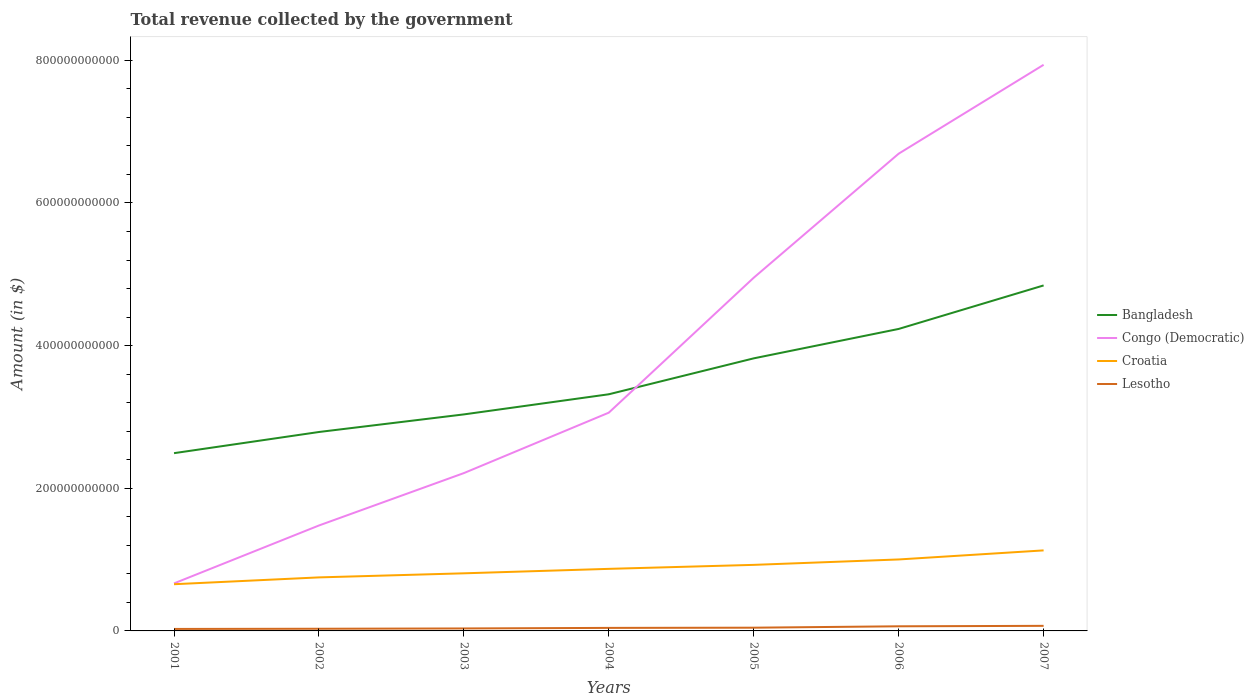How many different coloured lines are there?
Provide a short and direct response. 4. Does the line corresponding to Lesotho intersect with the line corresponding to Bangladesh?
Your answer should be compact. No. Across all years, what is the maximum total revenue collected by the government in Croatia?
Keep it short and to the point. 6.55e+1. In which year was the total revenue collected by the government in Croatia maximum?
Provide a short and direct response. 2001. What is the total total revenue collected by the government in Croatia in the graph?
Your response must be concise. -1.94e+1. What is the difference between the highest and the second highest total revenue collected by the government in Croatia?
Offer a terse response. 4.74e+1. How many lines are there?
Keep it short and to the point. 4. How many years are there in the graph?
Keep it short and to the point. 7. What is the difference between two consecutive major ticks on the Y-axis?
Provide a succinct answer. 2.00e+11. Are the values on the major ticks of Y-axis written in scientific E-notation?
Your answer should be very brief. No. Does the graph contain grids?
Provide a succinct answer. No. How many legend labels are there?
Offer a very short reply. 4. What is the title of the graph?
Your answer should be compact. Total revenue collected by the government. Does "Korea (Republic)" appear as one of the legend labels in the graph?
Offer a very short reply. No. What is the label or title of the Y-axis?
Your answer should be compact. Amount (in $). What is the Amount (in $) of Bangladesh in 2001?
Give a very brief answer. 2.49e+11. What is the Amount (in $) in Congo (Democratic) in 2001?
Provide a short and direct response. 6.66e+1. What is the Amount (in $) in Croatia in 2001?
Make the answer very short. 6.55e+1. What is the Amount (in $) in Lesotho in 2001?
Your answer should be very brief. 2.79e+09. What is the Amount (in $) of Bangladesh in 2002?
Give a very brief answer. 2.79e+11. What is the Amount (in $) in Congo (Democratic) in 2002?
Offer a very short reply. 1.48e+11. What is the Amount (in $) of Croatia in 2002?
Your answer should be compact. 7.51e+1. What is the Amount (in $) in Lesotho in 2002?
Your answer should be very brief. 3.03e+09. What is the Amount (in $) of Bangladesh in 2003?
Provide a succinct answer. 3.04e+11. What is the Amount (in $) of Congo (Democratic) in 2003?
Your answer should be compact. 2.21e+11. What is the Amount (in $) in Croatia in 2003?
Provide a succinct answer. 8.08e+1. What is the Amount (in $) of Lesotho in 2003?
Your answer should be very brief. 3.47e+09. What is the Amount (in $) in Bangladesh in 2004?
Your answer should be compact. 3.32e+11. What is the Amount (in $) of Congo (Democratic) in 2004?
Your response must be concise. 3.06e+11. What is the Amount (in $) of Croatia in 2004?
Give a very brief answer. 8.70e+1. What is the Amount (in $) of Lesotho in 2004?
Offer a very short reply. 4.25e+09. What is the Amount (in $) of Bangladesh in 2005?
Your answer should be compact. 3.82e+11. What is the Amount (in $) in Congo (Democratic) in 2005?
Your response must be concise. 4.95e+11. What is the Amount (in $) in Croatia in 2005?
Provide a succinct answer. 9.26e+1. What is the Amount (in $) of Lesotho in 2005?
Your answer should be compact. 4.53e+09. What is the Amount (in $) of Bangladesh in 2006?
Provide a succinct answer. 4.23e+11. What is the Amount (in $) in Congo (Democratic) in 2006?
Your answer should be compact. 6.69e+11. What is the Amount (in $) in Croatia in 2006?
Ensure brevity in your answer.  1.00e+11. What is the Amount (in $) of Lesotho in 2006?
Your answer should be compact. 6.49e+09. What is the Amount (in $) in Bangladesh in 2007?
Make the answer very short. 4.84e+11. What is the Amount (in $) of Congo (Democratic) in 2007?
Provide a succinct answer. 7.94e+11. What is the Amount (in $) in Croatia in 2007?
Your response must be concise. 1.13e+11. What is the Amount (in $) in Lesotho in 2007?
Give a very brief answer. 7.13e+09. Across all years, what is the maximum Amount (in $) in Bangladesh?
Ensure brevity in your answer.  4.84e+11. Across all years, what is the maximum Amount (in $) in Congo (Democratic)?
Give a very brief answer. 7.94e+11. Across all years, what is the maximum Amount (in $) of Croatia?
Your response must be concise. 1.13e+11. Across all years, what is the maximum Amount (in $) in Lesotho?
Your answer should be compact. 7.13e+09. Across all years, what is the minimum Amount (in $) in Bangladesh?
Your answer should be compact. 2.49e+11. Across all years, what is the minimum Amount (in $) in Congo (Democratic)?
Offer a very short reply. 6.66e+1. Across all years, what is the minimum Amount (in $) in Croatia?
Offer a very short reply. 6.55e+1. Across all years, what is the minimum Amount (in $) of Lesotho?
Offer a terse response. 2.79e+09. What is the total Amount (in $) in Bangladesh in the graph?
Ensure brevity in your answer.  2.45e+12. What is the total Amount (in $) of Congo (Democratic) in the graph?
Make the answer very short. 2.70e+12. What is the total Amount (in $) of Croatia in the graph?
Offer a terse response. 6.14e+11. What is the total Amount (in $) of Lesotho in the graph?
Your answer should be very brief. 3.17e+1. What is the difference between the Amount (in $) in Bangladesh in 2001 and that in 2002?
Keep it short and to the point. -2.97e+1. What is the difference between the Amount (in $) of Congo (Democratic) in 2001 and that in 2002?
Your answer should be compact. -8.12e+1. What is the difference between the Amount (in $) in Croatia in 2001 and that in 2002?
Keep it short and to the point. -9.58e+09. What is the difference between the Amount (in $) of Lesotho in 2001 and that in 2002?
Offer a terse response. -2.46e+08. What is the difference between the Amount (in $) in Bangladesh in 2001 and that in 2003?
Make the answer very short. -5.43e+1. What is the difference between the Amount (in $) of Congo (Democratic) in 2001 and that in 2003?
Your answer should be very brief. -1.55e+11. What is the difference between the Amount (in $) of Croatia in 2001 and that in 2003?
Keep it short and to the point. -1.53e+1. What is the difference between the Amount (in $) in Lesotho in 2001 and that in 2003?
Make the answer very short. -6.80e+08. What is the difference between the Amount (in $) of Bangladesh in 2001 and that in 2004?
Make the answer very short. -8.26e+1. What is the difference between the Amount (in $) of Congo (Democratic) in 2001 and that in 2004?
Offer a terse response. -2.39e+11. What is the difference between the Amount (in $) in Croatia in 2001 and that in 2004?
Make the answer very short. -2.15e+1. What is the difference between the Amount (in $) of Lesotho in 2001 and that in 2004?
Offer a terse response. -1.46e+09. What is the difference between the Amount (in $) of Bangladesh in 2001 and that in 2005?
Offer a terse response. -1.33e+11. What is the difference between the Amount (in $) in Congo (Democratic) in 2001 and that in 2005?
Ensure brevity in your answer.  -4.29e+11. What is the difference between the Amount (in $) in Croatia in 2001 and that in 2005?
Your response must be concise. -2.71e+1. What is the difference between the Amount (in $) of Lesotho in 2001 and that in 2005?
Offer a terse response. -1.75e+09. What is the difference between the Amount (in $) of Bangladesh in 2001 and that in 2006?
Provide a succinct answer. -1.74e+11. What is the difference between the Amount (in $) of Congo (Democratic) in 2001 and that in 2006?
Offer a very short reply. -6.03e+11. What is the difference between the Amount (in $) in Croatia in 2001 and that in 2006?
Offer a terse response. -3.47e+1. What is the difference between the Amount (in $) of Lesotho in 2001 and that in 2006?
Make the answer very short. -3.70e+09. What is the difference between the Amount (in $) of Bangladesh in 2001 and that in 2007?
Offer a terse response. -2.35e+11. What is the difference between the Amount (in $) of Congo (Democratic) in 2001 and that in 2007?
Keep it short and to the point. -7.27e+11. What is the difference between the Amount (in $) of Croatia in 2001 and that in 2007?
Offer a terse response. -4.74e+1. What is the difference between the Amount (in $) of Lesotho in 2001 and that in 2007?
Keep it short and to the point. -4.34e+09. What is the difference between the Amount (in $) in Bangladesh in 2002 and that in 2003?
Your answer should be compact. -2.47e+1. What is the difference between the Amount (in $) in Congo (Democratic) in 2002 and that in 2003?
Ensure brevity in your answer.  -7.35e+1. What is the difference between the Amount (in $) in Croatia in 2002 and that in 2003?
Provide a succinct answer. -5.71e+09. What is the difference between the Amount (in $) in Lesotho in 2002 and that in 2003?
Offer a very short reply. -4.34e+08. What is the difference between the Amount (in $) in Bangladesh in 2002 and that in 2004?
Your answer should be very brief. -5.29e+1. What is the difference between the Amount (in $) of Congo (Democratic) in 2002 and that in 2004?
Your answer should be very brief. -1.58e+11. What is the difference between the Amount (in $) in Croatia in 2002 and that in 2004?
Offer a very short reply. -1.19e+1. What is the difference between the Amount (in $) in Lesotho in 2002 and that in 2004?
Ensure brevity in your answer.  -1.22e+09. What is the difference between the Amount (in $) of Bangladesh in 2002 and that in 2005?
Make the answer very short. -1.03e+11. What is the difference between the Amount (in $) in Congo (Democratic) in 2002 and that in 2005?
Provide a short and direct response. -3.47e+11. What is the difference between the Amount (in $) in Croatia in 2002 and that in 2005?
Provide a short and direct response. -1.76e+1. What is the difference between the Amount (in $) of Lesotho in 2002 and that in 2005?
Offer a very short reply. -1.50e+09. What is the difference between the Amount (in $) of Bangladesh in 2002 and that in 2006?
Provide a short and direct response. -1.45e+11. What is the difference between the Amount (in $) in Congo (Democratic) in 2002 and that in 2006?
Your answer should be compact. -5.21e+11. What is the difference between the Amount (in $) in Croatia in 2002 and that in 2006?
Your answer should be compact. -2.51e+1. What is the difference between the Amount (in $) in Lesotho in 2002 and that in 2006?
Provide a succinct answer. -3.45e+09. What is the difference between the Amount (in $) in Bangladesh in 2002 and that in 2007?
Ensure brevity in your answer.  -2.06e+11. What is the difference between the Amount (in $) in Congo (Democratic) in 2002 and that in 2007?
Give a very brief answer. -6.46e+11. What is the difference between the Amount (in $) in Croatia in 2002 and that in 2007?
Make the answer very short. -3.78e+1. What is the difference between the Amount (in $) in Lesotho in 2002 and that in 2007?
Ensure brevity in your answer.  -4.09e+09. What is the difference between the Amount (in $) in Bangladesh in 2003 and that in 2004?
Your answer should be compact. -2.82e+1. What is the difference between the Amount (in $) of Congo (Democratic) in 2003 and that in 2004?
Offer a very short reply. -8.47e+1. What is the difference between the Amount (in $) in Croatia in 2003 and that in 2004?
Offer a terse response. -6.23e+09. What is the difference between the Amount (in $) in Lesotho in 2003 and that in 2004?
Your answer should be very brief. -7.84e+08. What is the difference between the Amount (in $) of Bangladesh in 2003 and that in 2005?
Offer a very short reply. -7.86e+1. What is the difference between the Amount (in $) of Congo (Democratic) in 2003 and that in 2005?
Provide a short and direct response. -2.74e+11. What is the difference between the Amount (in $) of Croatia in 2003 and that in 2005?
Your answer should be very brief. -1.18e+1. What is the difference between the Amount (in $) of Lesotho in 2003 and that in 2005?
Your answer should be compact. -1.07e+09. What is the difference between the Amount (in $) in Bangladesh in 2003 and that in 2006?
Offer a terse response. -1.20e+11. What is the difference between the Amount (in $) in Congo (Democratic) in 2003 and that in 2006?
Give a very brief answer. -4.48e+11. What is the difference between the Amount (in $) of Croatia in 2003 and that in 2006?
Your response must be concise. -1.94e+1. What is the difference between the Amount (in $) of Lesotho in 2003 and that in 2006?
Ensure brevity in your answer.  -3.02e+09. What is the difference between the Amount (in $) in Bangladesh in 2003 and that in 2007?
Offer a very short reply. -1.81e+11. What is the difference between the Amount (in $) of Congo (Democratic) in 2003 and that in 2007?
Offer a terse response. -5.72e+11. What is the difference between the Amount (in $) in Croatia in 2003 and that in 2007?
Provide a succinct answer. -3.21e+1. What is the difference between the Amount (in $) in Lesotho in 2003 and that in 2007?
Make the answer very short. -3.66e+09. What is the difference between the Amount (in $) in Bangladesh in 2004 and that in 2005?
Provide a short and direct response. -5.04e+1. What is the difference between the Amount (in $) of Congo (Democratic) in 2004 and that in 2005?
Provide a short and direct response. -1.89e+11. What is the difference between the Amount (in $) in Croatia in 2004 and that in 2005?
Make the answer very short. -5.61e+09. What is the difference between the Amount (in $) of Lesotho in 2004 and that in 2005?
Your answer should be compact. -2.81e+08. What is the difference between the Amount (in $) of Bangladesh in 2004 and that in 2006?
Keep it short and to the point. -9.16e+1. What is the difference between the Amount (in $) of Congo (Democratic) in 2004 and that in 2006?
Offer a very short reply. -3.63e+11. What is the difference between the Amount (in $) of Croatia in 2004 and that in 2006?
Your answer should be compact. -1.32e+1. What is the difference between the Amount (in $) in Lesotho in 2004 and that in 2006?
Provide a succinct answer. -2.23e+09. What is the difference between the Amount (in $) of Bangladesh in 2004 and that in 2007?
Your answer should be compact. -1.53e+11. What is the difference between the Amount (in $) of Congo (Democratic) in 2004 and that in 2007?
Your answer should be compact. -4.88e+11. What is the difference between the Amount (in $) in Croatia in 2004 and that in 2007?
Offer a terse response. -2.59e+1. What is the difference between the Amount (in $) in Lesotho in 2004 and that in 2007?
Provide a succinct answer. -2.87e+09. What is the difference between the Amount (in $) of Bangladesh in 2005 and that in 2006?
Make the answer very short. -4.12e+1. What is the difference between the Amount (in $) of Congo (Democratic) in 2005 and that in 2006?
Provide a short and direct response. -1.74e+11. What is the difference between the Amount (in $) in Croatia in 2005 and that in 2006?
Give a very brief answer. -7.58e+09. What is the difference between the Amount (in $) of Lesotho in 2005 and that in 2006?
Offer a terse response. -1.95e+09. What is the difference between the Amount (in $) in Bangladesh in 2005 and that in 2007?
Ensure brevity in your answer.  -1.02e+11. What is the difference between the Amount (in $) of Congo (Democratic) in 2005 and that in 2007?
Make the answer very short. -2.99e+11. What is the difference between the Amount (in $) of Croatia in 2005 and that in 2007?
Keep it short and to the point. -2.03e+1. What is the difference between the Amount (in $) of Lesotho in 2005 and that in 2007?
Offer a terse response. -2.59e+09. What is the difference between the Amount (in $) in Bangladesh in 2006 and that in 2007?
Provide a succinct answer. -6.10e+1. What is the difference between the Amount (in $) of Congo (Democratic) in 2006 and that in 2007?
Offer a terse response. -1.25e+11. What is the difference between the Amount (in $) of Croatia in 2006 and that in 2007?
Give a very brief answer. -1.27e+1. What is the difference between the Amount (in $) of Lesotho in 2006 and that in 2007?
Your response must be concise. -6.38e+08. What is the difference between the Amount (in $) of Bangladesh in 2001 and the Amount (in $) of Congo (Democratic) in 2002?
Make the answer very short. 1.01e+11. What is the difference between the Amount (in $) in Bangladesh in 2001 and the Amount (in $) in Croatia in 2002?
Provide a succinct answer. 1.74e+11. What is the difference between the Amount (in $) in Bangladesh in 2001 and the Amount (in $) in Lesotho in 2002?
Provide a succinct answer. 2.46e+11. What is the difference between the Amount (in $) in Congo (Democratic) in 2001 and the Amount (in $) in Croatia in 2002?
Your answer should be compact. -8.42e+09. What is the difference between the Amount (in $) of Congo (Democratic) in 2001 and the Amount (in $) of Lesotho in 2002?
Offer a very short reply. 6.36e+1. What is the difference between the Amount (in $) of Croatia in 2001 and the Amount (in $) of Lesotho in 2002?
Make the answer very short. 6.24e+1. What is the difference between the Amount (in $) in Bangladesh in 2001 and the Amount (in $) in Congo (Democratic) in 2003?
Make the answer very short. 2.79e+1. What is the difference between the Amount (in $) in Bangladesh in 2001 and the Amount (in $) in Croatia in 2003?
Offer a very short reply. 1.68e+11. What is the difference between the Amount (in $) in Bangladesh in 2001 and the Amount (in $) in Lesotho in 2003?
Your answer should be compact. 2.46e+11. What is the difference between the Amount (in $) in Congo (Democratic) in 2001 and the Amount (in $) in Croatia in 2003?
Your answer should be very brief. -1.41e+1. What is the difference between the Amount (in $) in Congo (Democratic) in 2001 and the Amount (in $) in Lesotho in 2003?
Make the answer very short. 6.32e+1. What is the difference between the Amount (in $) of Croatia in 2001 and the Amount (in $) of Lesotho in 2003?
Make the answer very short. 6.20e+1. What is the difference between the Amount (in $) of Bangladesh in 2001 and the Amount (in $) of Congo (Democratic) in 2004?
Ensure brevity in your answer.  -5.68e+1. What is the difference between the Amount (in $) of Bangladesh in 2001 and the Amount (in $) of Croatia in 2004?
Offer a terse response. 1.62e+11. What is the difference between the Amount (in $) of Bangladesh in 2001 and the Amount (in $) of Lesotho in 2004?
Your response must be concise. 2.45e+11. What is the difference between the Amount (in $) in Congo (Democratic) in 2001 and the Amount (in $) in Croatia in 2004?
Offer a terse response. -2.04e+1. What is the difference between the Amount (in $) in Congo (Democratic) in 2001 and the Amount (in $) in Lesotho in 2004?
Provide a succinct answer. 6.24e+1. What is the difference between the Amount (in $) in Croatia in 2001 and the Amount (in $) in Lesotho in 2004?
Provide a short and direct response. 6.12e+1. What is the difference between the Amount (in $) in Bangladesh in 2001 and the Amount (in $) in Congo (Democratic) in 2005?
Your answer should be compact. -2.46e+11. What is the difference between the Amount (in $) in Bangladesh in 2001 and the Amount (in $) in Croatia in 2005?
Give a very brief answer. 1.57e+11. What is the difference between the Amount (in $) in Bangladesh in 2001 and the Amount (in $) in Lesotho in 2005?
Offer a very short reply. 2.45e+11. What is the difference between the Amount (in $) of Congo (Democratic) in 2001 and the Amount (in $) of Croatia in 2005?
Your answer should be compact. -2.60e+1. What is the difference between the Amount (in $) in Congo (Democratic) in 2001 and the Amount (in $) in Lesotho in 2005?
Offer a very short reply. 6.21e+1. What is the difference between the Amount (in $) of Croatia in 2001 and the Amount (in $) of Lesotho in 2005?
Your answer should be very brief. 6.09e+1. What is the difference between the Amount (in $) of Bangladesh in 2001 and the Amount (in $) of Congo (Democratic) in 2006?
Offer a terse response. -4.20e+11. What is the difference between the Amount (in $) in Bangladesh in 2001 and the Amount (in $) in Croatia in 2006?
Your response must be concise. 1.49e+11. What is the difference between the Amount (in $) of Bangladesh in 2001 and the Amount (in $) of Lesotho in 2006?
Offer a very short reply. 2.43e+11. What is the difference between the Amount (in $) in Congo (Democratic) in 2001 and the Amount (in $) in Croatia in 2006?
Your answer should be compact. -3.36e+1. What is the difference between the Amount (in $) in Congo (Democratic) in 2001 and the Amount (in $) in Lesotho in 2006?
Offer a very short reply. 6.02e+1. What is the difference between the Amount (in $) of Croatia in 2001 and the Amount (in $) of Lesotho in 2006?
Provide a short and direct response. 5.90e+1. What is the difference between the Amount (in $) of Bangladesh in 2001 and the Amount (in $) of Congo (Democratic) in 2007?
Your response must be concise. -5.45e+11. What is the difference between the Amount (in $) in Bangladesh in 2001 and the Amount (in $) in Croatia in 2007?
Your response must be concise. 1.36e+11. What is the difference between the Amount (in $) in Bangladesh in 2001 and the Amount (in $) in Lesotho in 2007?
Ensure brevity in your answer.  2.42e+11. What is the difference between the Amount (in $) of Congo (Democratic) in 2001 and the Amount (in $) of Croatia in 2007?
Keep it short and to the point. -4.63e+1. What is the difference between the Amount (in $) of Congo (Democratic) in 2001 and the Amount (in $) of Lesotho in 2007?
Ensure brevity in your answer.  5.95e+1. What is the difference between the Amount (in $) in Croatia in 2001 and the Amount (in $) in Lesotho in 2007?
Your answer should be very brief. 5.84e+1. What is the difference between the Amount (in $) in Bangladesh in 2002 and the Amount (in $) in Congo (Democratic) in 2003?
Your response must be concise. 5.76e+1. What is the difference between the Amount (in $) in Bangladesh in 2002 and the Amount (in $) in Croatia in 2003?
Ensure brevity in your answer.  1.98e+11. What is the difference between the Amount (in $) in Bangladesh in 2002 and the Amount (in $) in Lesotho in 2003?
Provide a succinct answer. 2.75e+11. What is the difference between the Amount (in $) of Congo (Democratic) in 2002 and the Amount (in $) of Croatia in 2003?
Your response must be concise. 6.71e+1. What is the difference between the Amount (in $) of Congo (Democratic) in 2002 and the Amount (in $) of Lesotho in 2003?
Give a very brief answer. 1.44e+11. What is the difference between the Amount (in $) in Croatia in 2002 and the Amount (in $) in Lesotho in 2003?
Keep it short and to the point. 7.16e+1. What is the difference between the Amount (in $) in Bangladesh in 2002 and the Amount (in $) in Congo (Democratic) in 2004?
Your answer should be very brief. -2.71e+1. What is the difference between the Amount (in $) in Bangladesh in 2002 and the Amount (in $) in Croatia in 2004?
Give a very brief answer. 1.92e+11. What is the difference between the Amount (in $) of Bangladesh in 2002 and the Amount (in $) of Lesotho in 2004?
Your answer should be compact. 2.75e+11. What is the difference between the Amount (in $) of Congo (Democratic) in 2002 and the Amount (in $) of Croatia in 2004?
Provide a short and direct response. 6.08e+1. What is the difference between the Amount (in $) of Congo (Democratic) in 2002 and the Amount (in $) of Lesotho in 2004?
Your response must be concise. 1.44e+11. What is the difference between the Amount (in $) in Croatia in 2002 and the Amount (in $) in Lesotho in 2004?
Keep it short and to the point. 7.08e+1. What is the difference between the Amount (in $) of Bangladesh in 2002 and the Amount (in $) of Congo (Democratic) in 2005?
Your response must be concise. -2.16e+11. What is the difference between the Amount (in $) of Bangladesh in 2002 and the Amount (in $) of Croatia in 2005?
Offer a very short reply. 1.86e+11. What is the difference between the Amount (in $) of Bangladesh in 2002 and the Amount (in $) of Lesotho in 2005?
Offer a very short reply. 2.74e+11. What is the difference between the Amount (in $) in Congo (Democratic) in 2002 and the Amount (in $) in Croatia in 2005?
Ensure brevity in your answer.  5.52e+1. What is the difference between the Amount (in $) in Congo (Democratic) in 2002 and the Amount (in $) in Lesotho in 2005?
Give a very brief answer. 1.43e+11. What is the difference between the Amount (in $) in Croatia in 2002 and the Amount (in $) in Lesotho in 2005?
Provide a succinct answer. 7.05e+1. What is the difference between the Amount (in $) of Bangladesh in 2002 and the Amount (in $) of Congo (Democratic) in 2006?
Your answer should be very brief. -3.90e+11. What is the difference between the Amount (in $) in Bangladesh in 2002 and the Amount (in $) in Croatia in 2006?
Your response must be concise. 1.79e+11. What is the difference between the Amount (in $) in Bangladesh in 2002 and the Amount (in $) in Lesotho in 2006?
Provide a succinct answer. 2.72e+11. What is the difference between the Amount (in $) of Congo (Democratic) in 2002 and the Amount (in $) of Croatia in 2006?
Make the answer very short. 4.76e+1. What is the difference between the Amount (in $) in Congo (Democratic) in 2002 and the Amount (in $) in Lesotho in 2006?
Make the answer very short. 1.41e+11. What is the difference between the Amount (in $) in Croatia in 2002 and the Amount (in $) in Lesotho in 2006?
Ensure brevity in your answer.  6.86e+1. What is the difference between the Amount (in $) of Bangladesh in 2002 and the Amount (in $) of Congo (Democratic) in 2007?
Your response must be concise. -5.15e+11. What is the difference between the Amount (in $) of Bangladesh in 2002 and the Amount (in $) of Croatia in 2007?
Offer a terse response. 1.66e+11. What is the difference between the Amount (in $) in Bangladesh in 2002 and the Amount (in $) in Lesotho in 2007?
Offer a terse response. 2.72e+11. What is the difference between the Amount (in $) in Congo (Democratic) in 2002 and the Amount (in $) in Croatia in 2007?
Make the answer very short. 3.49e+1. What is the difference between the Amount (in $) in Congo (Democratic) in 2002 and the Amount (in $) in Lesotho in 2007?
Offer a very short reply. 1.41e+11. What is the difference between the Amount (in $) in Croatia in 2002 and the Amount (in $) in Lesotho in 2007?
Provide a succinct answer. 6.79e+1. What is the difference between the Amount (in $) of Bangladesh in 2003 and the Amount (in $) of Congo (Democratic) in 2004?
Offer a terse response. -2.44e+09. What is the difference between the Amount (in $) of Bangladesh in 2003 and the Amount (in $) of Croatia in 2004?
Make the answer very short. 2.17e+11. What is the difference between the Amount (in $) of Bangladesh in 2003 and the Amount (in $) of Lesotho in 2004?
Your answer should be very brief. 2.99e+11. What is the difference between the Amount (in $) of Congo (Democratic) in 2003 and the Amount (in $) of Croatia in 2004?
Your answer should be very brief. 1.34e+11. What is the difference between the Amount (in $) of Congo (Democratic) in 2003 and the Amount (in $) of Lesotho in 2004?
Your answer should be compact. 2.17e+11. What is the difference between the Amount (in $) in Croatia in 2003 and the Amount (in $) in Lesotho in 2004?
Provide a short and direct response. 7.65e+1. What is the difference between the Amount (in $) of Bangladesh in 2003 and the Amount (in $) of Congo (Democratic) in 2005?
Make the answer very short. -1.92e+11. What is the difference between the Amount (in $) of Bangladesh in 2003 and the Amount (in $) of Croatia in 2005?
Ensure brevity in your answer.  2.11e+11. What is the difference between the Amount (in $) in Bangladesh in 2003 and the Amount (in $) in Lesotho in 2005?
Offer a very short reply. 2.99e+11. What is the difference between the Amount (in $) in Congo (Democratic) in 2003 and the Amount (in $) in Croatia in 2005?
Your response must be concise. 1.29e+11. What is the difference between the Amount (in $) in Congo (Democratic) in 2003 and the Amount (in $) in Lesotho in 2005?
Your answer should be very brief. 2.17e+11. What is the difference between the Amount (in $) in Croatia in 2003 and the Amount (in $) in Lesotho in 2005?
Your answer should be compact. 7.62e+1. What is the difference between the Amount (in $) in Bangladesh in 2003 and the Amount (in $) in Congo (Democratic) in 2006?
Your response must be concise. -3.66e+11. What is the difference between the Amount (in $) in Bangladesh in 2003 and the Amount (in $) in Croatia in 2006?
Ensure brevity in your answer.  2.03e+11. What is the difference between the Amount (in $) in Bangladesh in 2003 and the Amount (in $) in Lesotho in 2006?
Keep it short and to the point. 2.97e+11. What is the difference between the Amount (in $) in Congo (Democratic) in 2003 and the Amount (in $) in Croatia in 2006?
Your answer should be very brief. 1.21e+11. What is the difference between the Amount (in $) of Congo (Democratic) in 2003 and the Amount (in $) of Lesotho in 2006?
Your answer should be compact. 2.15e+11. What is the difference between the Amount (in $) of Croatia in 2003 and the Amount (in $) of Lesotho in 2006?
Provide a short and direct response. 7.43e+1. What is the difference between the Amount (in $) in Bangladesh in 2003 and the Amount (in $) in Congo (Democratic) in 2007?
Offer a terse response. -4.90e+11. What is the difference between the Amount (in $) in Bangladesh in 2003 and the Amount (in $) in Croatia in 2007?
Provide a short and direct response. 1.91e+11. What is the difference between the Amount (in $) in Bangladesh in 2003 and the Amount (in $) in Lesotho in 2007?
Provide a short and direct response. 2.96e+11. What is the difference between the Amount (in $) in Congo (Democratic) in 2003 and the Amount (in $) in Croatia in 2007?
Your answer should be compact. 1.08e+11. What is the difference between the Amount (in $) of Congo (Democratic) in 2003 and the Amount (in $) of Lesotho in 2007?
Make the answer very short. 2.14e+11. What is the difference between the Amount (in $) in Croatia in 2003 and the Amount (in $) in Lesotho in 2007?
Your response must be concise. 7.36e+1. What is the difference between the Amount (in $) of Bangladesh in 2004 and the Amount (in $) of Congo (Democratic) in 2005?
Provide a succinct answer. -1.63e+11. What is the difference between the Amount (in $) in Bangladesh in 2004 and the Amount (in $) in Croatia in 2005?
Provide a short and direct response. 2.39e+11. What is the difference between the Amount (in $) in Bangladesh in 2004 and the Amount (in $) in Lesotho in 2005?
Make the answer very short. 3.27e+11. What is the difference between the Amount (in $) in Congo (Democratic) in 2004 and the Amount (in $) in Croatia in 2005?
Make the answer very short. 2.13e+11. What is the difference between the Amount (in $) in Congo (Democratic) in 2004 and the Amount (in $) in Lesotho in 2005?
Make the answer very short. 3.01e+11. What is the difference between the Amount (in $) of Croatia in 2004 and the Amount (in $) of Lesotho in 2005?
Offer a very short reply. 8.25e+1. What is the difference between the Amount (in $) of Bangladesh in 2004 and the Amount (in $) of Congo (Democratic) in 2006?
Your answer should be compact. -3.37e+11. What is the difference between the Amount (in $) in Bangladesh in 2004 and the Amount (in $) in Croatia in 2006?
Ensure brevity in your answer.  2.32e+11. What is the difference between the Amount (in $) in Bangladesh in 2004 and the Amount (in $) in Lesotho in 2006?
Ensure brevity in your answer.  3.25e+11. What is the difference between the Amount (in $) in Congo (Democratic) in 2004 and the Amount (in $) in Croatia in 2006?
Provide a short and direct response. 2.06e+11. What is the difference between the Amount (in $) of Congo (Democratic) in 2004 and the Amount (in $) of Lesotho in 2006?
Your answer should be compact. 3.00e+11. What is the difference between the Amount (in $) in Croatia in 2004 and the Amount (in $) in Lesotho in 2006?
Give a very brief answer. 8.05e+1. What is the difference between the Amount (in $) of Bangladesh in 2004 and the Amount (in $) of Congo (Democratic) in 2007?
Your response must be concise. -4.62e+11. What is the difference between the Amount (in $) in Bangladesh in 2004 and the Amount (in $) in Croatia in 2007?
Make the answer very short. 2.19e+11. What is the difference between the Amount (in $) in Bangladesh in 2004 and the Amount (in $) in Lesotho in 2007?
Your response must be concise. 3.25e+11. What is the difference between the Amount (in $) of Congo (Democratic) in 2004 and the Amount (in $) of Croatia in 2007?
Ensure brevity in your answer.  1.93e+11. What is the difference between the Amount (in $) in Congo (Democratic) in 2004 and the Amount (in $) in Lesotho in 2007?
Make the answer very short. 2.99e+11. What is the difference between the Amount (in $) in Croatia in 2004 and the Amount (in $) in Lesotho in 2007?
Make the answer very short. 7.99e+1. What is the difference between the Amount (in $) in Bangladesh in 2005 and the Amount (in $) in Congo (Democratic) in 2006?
Give a very brief answer. -2.87e+11. What is the difference between the Amount (in $) of Bangladesh in 2005 and the Amount (in $) of Croatia in 2006?
Offer a very short reply. 2.82e+11. What is the difference between the Amount (in $) of Bangladesh in 2005 and the Amount (in $) of Lesotho in 2006?
Your response must be concise. 3.76e+11. What is the difference between the Amount (in $) of Congo (Democratic) in 2005 and the Amount (in $) of Croatia in 2006?
Make the answer very short. 3.95e+11. What is the difference between the Amount (in $) of Congo (Democratic) in 2005 and the Amount (in $) of Lesotho in 2006?
Your answer should be compact. 4.89e+11. What is the difference between the Amount (in $) of Croatia in 2005 and the Amount (in $) of Lesotho in 2006?
Your response must be concise. 8.61e+1. What is the difference between the Amount (in $) of Bangladesh in 2005 and the Amount (in $) of Congo (Democratic) in 2007?
Offer a very short reply. -4.12e+11. What is the difference between the Amount (in $) of Bangladesh in 2005 and the Amount (in $) of Croatia in 2007?
Make the answer very short. 2.69e+11. What is the difference between the Amount (in $) of Bangladesh in 2005 and the Amount (in $) of Lesotho in 2007?
Your answer should be compact. 3.75e+11. What is the difference between the Amount (in $) of Congo (Democratic) in 2005 and the Amount (in $) of Croatia in 2007?
Make the answer very short. 3.82e+11. What is the difference between the Amount (in $) in Congo (Democratic) in 2005 and the Amount (in $) in Lesotho in 2007?
Make the answer very short. 4.88e+11. What is the difference between the Amount (in $) of Croatia in 2005 and the Amount (in $) of Lesotho in 2007?
Ensure brevity in your answer.  8.55e+1. What is the difference between the Amount (in $) of Bangladesh in 2006 and the Amount (in $) of Congo (Democratic) in 2007?
Offer a terse response. -3.70e+11. What is the difference between the Amount (in $) of Bangladesh in 2006 and the Amount (in $) of Croatia in 2007?
Keep it short and to the point. 3.11e+11. What is the difference between the Amount (in $) in Bangladesh in 2006 and the Amount (in $) in Lesotho in 2007?
Provide a succinct answer. 4.16e+11. What is the difference between the Amount (in $) of Congo (Democratic) in 2006 and the Amount (in $) of Croatia in 2007?
Your response must be concise. 5.56e+11. What is the difference between the Amount (in $) in Congo (Democratic) in 2006 and the Amount (in $) in Lesotho in 2007?
Your answer should be compact. 6.62e+11. What is the difference between the Amount (in $) of Croatia in 2006 and the Amount (in $) of Lesotho in 2007?
Offer a very short reply. 9.31e+1. What is the average Amount (in $) in Bangladesh per year?
Make the answer very short. 3.51e+11. What is the average Amount (in $) in Congo (Democratic) per year?
Give a very brief answer. 3.86e+11. What is the average Amount (in $) in Croatia per year?
Offer a terse response. 8.77e+1. What is the average Amount (in $) in Lesotho per year?
Provide a short and direct response. 4.53e+09. In the year 2001, what is the difference between the Amount (in $) of Bangladesh and Amount (in $) of Congo (Democratic)?
Your answer should be compact. 1.83e+11. In the year 2001, what is the difference between the Amount (in $) in Bangladesh and Amount (in $) in Croatia?
Provide a succinct answer. 1.84e+11. In the year 2001, what is the difference between the Amount (in $) in Bangladesh and Amount (in $) in Lesotho?
Offer a very short reply. 2.46e+11. In the year 2001, what is the difference between the Amount (in $) of Congo (Democratic) and Amount (in $) of Croatia?
Your answer should be very brief. 1.16e+09. In the year 2001, what is the difference between the Amount (in $) in Congo (Democratic) and Amount (in $) in Lesotho?
Offer a very short reply. 6.39e+1. In the year 2001, what is the difference between the Amount (in $) in Croatia and Amount (in $) in Lesotho?
Offer a terse response. 6.27e+1. In the year 2002, what is the difference between the Amount (in $) of Bangladesh and Amount (in $) of Congo (Democratic)?
Give a very brief answer. 1.31e+11. In the year 2002, what is the difference between the Amount (in $) of Bangladesh and Amount (in $) of Croatia?
Your response must be concise. 2.04e+11. In the year 2002, what is the difference between the Amount (in $) of Bangladesh and Amount (in $) of Lesotho?
Keep it short and to the point. 2.76e+11. In the year 2002, what is the difference between the Amount (in $) in Congo (Democratic) and Amount (in $) in Croatia?
Your response must be concise. 7.28e+1. In the year 2002, what is the difference between the Amount (in $) of Congo (Democratic) and Amount (in $) of Lesotho?
Offer a terse response. 1.45e+11. In the year 2002, what is the difference between the Amount (in $) in Croatia and Amount (in $) in Lesotho?
Offer a very short reply. 7.20e+1. In the year 2003, what is the difference between the Amount (in $) in Bangladesh and Amount (in $) in Congo (Democratic)?
Provide a short and direct response. 8.23e+1. In the year 2003, what is the difference between the Amount (in $) of Bangladesh and Amount (in $) of Croatia?
Give a very brief answer. 2.23e+11. In the year 2003, what is the difference between the Amount (in $) of Bangladesh and Amount (in $) of Lesotho?
Provide a short and direct response. 3.00e+11. In the year 2003, what is the difference between the Amount (in $) in Congo (Democratic) and Amount (in $) in Croatia?
Your response must be concise. 1.41e+11. In the year 2003, what is the difference between the Amount (in $) of Congo (Democratic) and Amount (in $) of Lesotho?
Offer a very short reply. 2.18e+11. In the year 2003, what is the difference between the Amount (in $) in Croatia and Amount (in $) in Lesotho?
Your response must be concise. 7.73e+1. In the year 2004, what is the difference between the Amount (in $) in Bangladesh and Amount (in $) in Congo (Democratic)?
Give a very brief answer. 2.58e+1. In the year 2004, what is the difference between the Amount (in $) of Bangladesh and Amount (in $) of Croatia?
Give a very brief answer. 2.45e+11. In the year 2004, what is the difference between the Amount (in $) of Bangladesh and Amount (in $) of Lesotho?
Make the answer very short. 3.28e+11. In the year 2004, what is the difference between the Amount (in $) of Congo (Democratic) and Amount (in $) of Croatia?
Provide a short and direct response. 2.19e+11. In the year 2004, what is the difference between the Amount (in $) in Congo (Democratic) and Amount (in $) in Lesotho?
Give a very brief answer. 3.02e+11. In the year 2004, what is the difference between the Amount (in $) of Croatia and Amount (in $) of Lesotho?
Provide a succinct answer. 8.28e+1. In the year 2005, what is the difference between the Amount (in $) of Bangladesh and Amount (in $) of Congo (Democratic)?
Your answer should be very brief. -1.13e+11. In the year 2005, what is the difference between the Amount (in $) of Bangladesh and Amount (in $) of Croatia?
Keep it short and to the point. 2.90e+11. In the year 2005, what is the difference between the Amount (in $) in Bangladesh and Amount (in $) in Lesotho?
Offer a very short reply. 3.78e+11. In the year 2005, what is the difference between the Amount (in $) in Congo (Democratic) and Amount (in $) in Croatia?
Provide a succinct answer. 4.03e+11. In the year 2005, what is the difference between the Amount (in $) of Congo (Democratic) and Amount (in $) of Lesotho?
Your answer should be compact. 4.91e+11. In the year 2005, what is the difference between the Amount (in $) in Croatia and Amount (in $) in Lesotho?
Give a very brief answer. 8.81e+1. In the year 2006, what is the difference between the Amount (in $) of Bangladesh and Amount (in $) of Congo (Democratic)?
Your answer should be compact. -2.46e+11. In the year 2006, what is the difference between the Amount (in $) in Bangladesh and Amount (in $) in Croatia?
Offer a very short reply. 3.23e+11. In the year 2006, what is the difference between the Amount (in $) in Bangladesh and Amount (in $) in Lesotho?
Make the answer very short. 4.17e+11. In the year 2006, what is the difference between the Amount (in $) of Congo (Democratic) and Amount (in $) of Croatia?
Your response must be concise. 5.69e+11. In the year 2006, what is the difference between the Amount (in $) in Congo (Democratic) and Amount (in $) in Lesotho?
Keep it short and to the point. 6.63e+11. In the year 2006, what is the difference between the Amount (in $) of Croatia and Amount (in $) of Lesotho?
Provide a succinct answer. 9.37e+1. In the year 2007, what is the difference between the Amount (in $) in Bangladesh and Amount (in $) in Congo (Democratic)?
Your response must be concise. -3.09e+11. In the year 2007, what is the difference between the Amount (in $) in Bangladesh and Amount (in $) in Croatia?
Ensure brevity in your answer.  3.72e+11. In the year 2007, what is the difference between the Amount (in $) in Bangladesh and Amount (in $) in Lesotho?
Make the answer very short. 4.77e+11. In the year 2007, what is the difference between the Amount (in $) of Congo (Democratic) and Amount (in $) of Croatia?
Provide a short and direct response. 6.81e+11. In the year 2007, what is the difference between the Amount (in $) in Congo (Democratic) and Amount (in $) in Lesotho?
Your answer should be compact. 7.87e+11. In the year 2007, what is the difference between the Amount (in $) of Croatia and Amount (in $) of Lesotho?
Offer a terse response. 1.06e+11. What is the ratio of the Amount (in $) in Bangladesh in 2001 to that in 2002?
Offer a very short reply. 0.89. What is the ratio of the Amount (in $) of Congo (Democratic) in 2001 to that in 2002?
Your answer should be very brief. 0.45. What is the ratio of the Amount (in $) in Croatia in 2001 to that in 2002?
Offer a very short reply. 0.87. What is the ratio of the Amount (in $) in Lesotho in 2001 to that in 2002?
Your answer should be compact. 0.92. What is the ratio of the Amount (in $) in Bangladesh in 2001 to that in 2003?
Offer a very short reply. 0.82. What is the ratio of the Amount (in $) in Congo (Democratic) in 2001 to that in 2003?
Provide a short and direct response. 0.3. What is the ratio of the Amount (in $) in Croatia in 2001 to that in 2003?
Your answer should be very brief. 0.81. What is the ratio of the Amount (in $) of Lesotho in 2001 to that in 2003?
Your answer should be very brief. 0.8. What is the ratio of the Amount (in $) of Bangladesh in 2001 to that in 2004?
Your answer should be compact. 0.75. What is the ratio of the Amount (in $) in Congo (Democratic) in 2001 to that in 2004?
Your response must be concise. 0.22. What is the ratio of the Amount (in $) in Croatia in 2001 to that in 2004?
Ensure brevity in your answer.  0.75. What is the ratio of the Amount (in $) of Lesotho in 2001 to that in 2004?
Make the answer very short. 0.66. What is the ratio of the Amount (in $) in Bangladesh in 2001 to that in 2005?
Provide a short and direct response. 0.65. What is the ratio of the Amount (in $) in Congo (Democratic) in 2001 to that in 2005?
Ensure brevity in your answer.  0.13. What is the ratio of the Amount (in $) of Croatia in 2001 to that in 2005?
Offer a terse response. 0.71. What is the ratio of the Amount (in $) in Lesotho in 2001 to that in 2005?
Give a very brief answer. 0.61. What is the ratio of the Amount (in $) in Bangladesh in 2001 to that in 2006?
Provide a succinct answer. 0.59. What is the ratio of the Amount (in $) in Congo (Democratic) in 2001 to that in 2006?
Offer a very short reply. 0.1. What is the ratio of the Amount (in $) in Croatia in 2001 to that in 2006?
Offer a terse response. 0.65. What is the ratio of the Amount (in $) in Lesotho in 2001 to that in 2006?
Give a very brief answer. 0.43. What is the ratio of the Amount (in $) of Bangladesh in 2001 to that in 2007?
Keep it short and to the point. 0.51. What is the ratio of the Amount (in $) of Congo (Democratic) in 2001 to that in 2007?
Offer a very short reply. 0.08. What is the ratio of the Amount (in $) in Croatia in 2001 to that in 2007?
Offer a terse response. 0.58. What is the ratio of the Amount (in $) in Lesotho in 2001 to that in 2007?
Your response must be concise. 0.39. What is the ratio of the Amount (in $) of Bangladesh in 2002 to that in 2003?
Provide a short and direct response. 0.92. What is the ratio of the Amount (in $) in Congo (Democratic) in 2002 to that in 2003?
Offer a very short reply. 0.67. What is the ratio of the Amount (in $) of Croatia in 2002 to that in 2003?
Give a very brief answer. 0.93. What is the ratio of the Amount (in $) of Lesotho in 2002 to that in 2003?
Provide a succinct answer. 0.87. What is the ratio of the Amount (in $) of Bangladesh in 2002 to that in 2004?
Ensure brevity in your answer.  0.84. What is the ratio of the Amount (in $) of Congo (Democratic) in 2002 to that in 2004?
Offer a terse response. 0.48. What is the ratio of the Amount (in $) of Croatia in 2002 to that in 2004?
Your answer should be very brief. 0.86. What is the ratio of the Amount (in $) in Lesotho in 2002 to that in 2004?
Your response must be concise. 0.71. What is the ratio of the Amount (in $) in Bangladesh in 2002 to that in 2005?
Offer a very short reply. 0.73. What is the ratio of the Amount (in $) in Congo (Democratic) in 2002 to that in 2005?
Provide a short and direct response. 0.3. What is the ratio of the Amount (in $) of Croatia in 2002 to that in 2005?
Your response must be concise. 0.81. What is the ratio of the Amount (in $) in Lesotho in 2002 to that in 2005?
Give a very brief answer. 0.67. What is the ratio of the Amount (in $) in Bangladesh in 2002 to that in 2006?
Your answer should be compact. 0.66. What is the ratio of the Amount (in $) of Congo (Democratic) in 2002 to that in 2006?
Ensure brevity in your answer.  0.22. What is the ratio of the Amount (in $) of Croatia in 2002 to that in 2006?
Offer a terse response. 0.75. What is the ratio of the Amount (in $) in Lesotho in 2002 to that in 2006?
Make the answer very short. 0.47. What is the ratio of the Amount (in $) in Bangladesh in 2002 to that in 2007?
Make the answer very short. 0.58. What is the ratio of the Amount (in $) in Congo (Democratic) in 2002 to that in 2007?
Give a very brief answer. 0.19. What is the ratio of the Amount (in $) of Croatia in 2002 to that in 2007?
Offer a terse response. 0.66. What is the ratio of the Amount (in $) of Lesotho in 2002 to that in 2007?
Provide a succinct answer. 0.43. What is the ratio of the Amount (in $) of Bangladesh in 2003 to that in 2004?
Provide a succinct answer. 0.92. What is the ratio of the Amount (in $) in Congo (Democratic) in 2003 to that in 2004?
Ensure brevity in your answer.  0.72. What is the ratio of the Amount (in $) in Croatia in 2003 to that in 2004?
Ensure brevity in your answer.  0.93. What is the ratio of the Amount (in $) of Lesotho in 2003 to that in 2004?
Provide a short and direct response. 0.82. What is the ratio of the Amount (in $) in Bangladesh in 2003 to that in 2005?
Provide a succinct answer. 0.79. What is the ratio of the Amount (in $) of Congo (Democratic) in 2003 to that in 2005?
Offer a terse response. 0.45. What is the ratio of the Amount (in $) of Croatia in 2003 to that in 2005?
Your answer should be compact. 0.87. What is the ratio of the Amount (in $) of Lesotho in 2003 to that in 2005?
Make the answer very short. 0.77. What is the ratio of the Amount (in $) in Bangladesh in 2003 to that in 2006?
Provide a short and direct response. 0.72. What is the ratio of the Amount (in $) of Congo (Democratic) in 2003 to that in 2006?
Offer a terse response. 0.33. What is the ratio of the Amount (in $) of Croatia in 2003 to that in 2006?
Provide a short and direct response. 0.81. What is the ratio of the Amount (in $) in Lesotho in 2003 to that in 2006?
Ensure brevity in your answer.  0.53. What is the ratio of the Amount (in $) of Bangladesh in 2003 to that in 2007?
Provide a short and direct response. 0.63. What is the ratio of the Amount (in $) in Congo (Democratic) in 2003 to that in 2007?
Give a very brief answer. 0.28. What is the ratio of the Amount (in $) in Croatia in 2003 to that in 2007?
Provide a succinct answer. 0.72. What is the ratio of the Amount (in $) of Lesotho in 2003 to that in 2007?
Provide a short and direct response. 0.49. What is the ratio of the Amount (in $) of Bangladesh in 2004 to that in 2005?
Offer a terse response. 0.87. What is the ratio of the Amount (in $) of Congo (Democratic) in 2004 to that in 2005?
Keep it short and to the point. 0.62. What is the ratio of the Amount (in $) in Croatia in 2004 to that in 2005?
Provide a short and direct response. 0.94. What is the ratio of the Amount (in $) in Lesotho in 2004 to that in 2005?
Keep it short and to the point. 0.94. What is the ratio of the Amount (in $) in Bangladesh in 2004 to that in 2006?
Give a very brief answer. 0.78. What is the ratio of the Amount (in $) in Congo (Democratic) in 2004 to that in 2006?
Make the answer very short. 0.46. What is the ratio of the Amount (in $) of Croatia in 2004 to that in 2006?
Offer a very short reply. 0.87. What is the ratio of the Amount (in $) in Lesotho in 2004 to that in 2006?
Make the answer very short. 0.66. What is the ratio of the Amount (in $) in Bangladesh in 2004 to that in 2007?
Your response must be concise. 0.69. What is the ratio of the Amount (in $) in Congo (Democratic) in 2004 to that in 2007?
Your answer should be very brief. 0.39. What is the ratio of the Amount (in $) of Croatia in 2004 to that in 2007?
Offer a terse response. 0.77. What is the ratio of the Amount (in $) in Lesotho in 2004 to that in 2007?
Your answer should be compact. 0.6. What is the ratio of the Amount (in $) of Bangladesh in 2005 to that in 2006?
Make the answer very short. 0.9. What is the ratio of the Amount (in $) in Congo (Democratic) in 2005 to that in 2006?
Give a very brief answer. 0.74. What is the ratio of the Amount (in $) of Croatia in 2005 to that in 2006?
Your response must be concise. 0.92. What is the ratio of the Amount (in $) in Lesotho in 2005 to that in 2006?
Provide a short and direct response. 0.7. What is the ratio of the Amount (in $) of Bangladesh in 2005 to that in 2007?
Your response must be concise. 0.79. What is the ratio of the Amount (in $) in Congo (Democratic) in 2005 to that in 2007?
Offer a very short reply. 0.62. What is the ratio of the Amount (in $) of Croatia in 2005 to that in 2007?
Your answer should be compact. 0.82. What is the ratio of the Amount (in $) in Lesotho in 2005 to that in 2007?
Give a very brief answer. 0.64. What is the ratio of the Amount (in $) in Bangladesh in 2006 to that in 2007?
Provide a succinct answer. 0.87. What is the ratio of the Amount (in $) in Congo (Democratic) in 2006 to that in 2007?
Your answer should be compact. 0.84. What is the ratio of the Amount (in $) in Croatia in 2006 to that in 2007?
Provide a succinct answer. 0.89. What is the ratio of the Amount (in $) in Lesotho in 2006 to that in 2007?
Keep it short and to the point. 0.91. What is the difference between the highest and the second highest Amount (in $) of Bangladesh?
Offer a terse response. 6.10e+1. What is the difference between the highest and the second highest Amount (in $) in Congo (Democratic)?
Make the answer very short. 1.25e+11. What is the difference between the highest and the second highest Amount (in $) in Croatia?
Your answer should be compact. 1.27e+1. What is the difference between the highest and the second highest Amount (in $) of Lesotho?
Provide a short and direct response. 6.38e+08. What is the difference between the highest and the lowest Amount (in $) in Bangladesh?
Your response must be concise. 2.35e+11. What is the difference between the highest and the lowest Amount (in $) in Congo (Democratic)?
Keep it short and to the point. 7.27e+11. What is the difference between the highest and the lowest Amount (in $) of Croatia?
Ensure brevity in your answer.  4.74e+1. What is the difference between the highest and the lowest Amount (in $) of Lesotho?
Keep it short and to the point. 4.34e+09. 